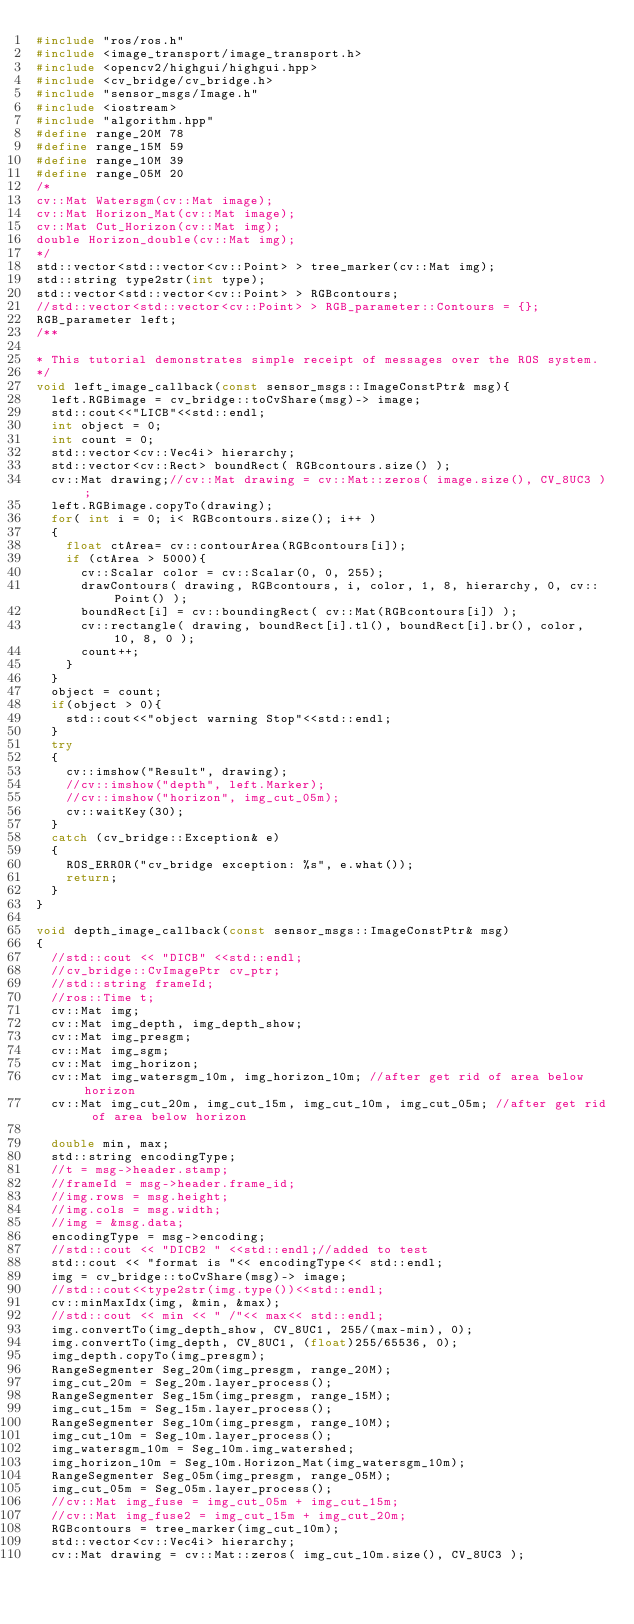<code> <loc_0><loc_0><loc_500><loc_500><_C++_>#include "ros/ros.h"
#include <image_transport/image_transport.h>
#include <opencv2/highgui/highgui.hpp>
#include <cv_bridge/cv_bridge.h>
#include "sensor_msgs/Image.h"
#include <iostream>
#include "algorithm.hpp"
#define range_20M 78
#define range_15M 59
#define range_10M 39
#define range_05M 20
/*
cv::Mat Watersgm(cv::Mat image);
cv::Mat Horizon_Mat(cv::Mat image);
cv::Mat Cut_Horizon(cv::Mat img);
double Horizon_double(cv::Mat img);
*/
std::vector<std::vector<cv::Point> > tree_marker(cv::Mat img);
std::string type2str(int type);
std::vector<std::vector<cv::Point> > RGBcontours;
//std::vector<std::vector<cv::Point> > RGB_parameter::Contours = {};
RGB_parameter left;
/**

* This tutorial demonstrates simple receipt of messages over the ROS system.
*/
void left_image_callback(const sensor_msgs::ImageConstPtr& msg){
	left.RGBimage = cv_bridge::toCvShare(msg)-> image;
	std::cout<<"LICB"<<std::endl;
	int object = 0;
	int count = 0;
	std::vector<cv::Vec4i> hierarchy;
	std::vector<cv::Rect> boundRect( RGBcontours.size() );
	cv::Mat drawing;//cv::Mat drawing = cv::Mat::zeros( image.size(), CV_8UC3 );
	left.RGBimage.copyTo(drawing);
	for( int i = 0; i< RGBcontours.size(); i++ )
	{
		float ctArea= cv::contourArea(RGBcontours[i]);
		if (ctArea > 5000){
			cv::Scalar color = cv::Scalar(0, 0, 255);
			drawContours( drawing, RGBcontours, i, color, 1, 8, hierarchy, 0, cv::Point() );
			boundRect[i] = cv::boundingRect( cv::Mat(RGBcontours[i]) );
			cv::rectangle( drawing, boundRect[i].tl(), boundRect[i].br(), color, 10, 8, 0 );
			count++;
		}
	}
	object = count;
	if(object > 0){
		std::cout<<"object warning Stop"<<std::endl;
	}
	try
	{
		cv::imshow("Result", drawing);
		//cv::imshow("depth", left.Marker);
		//cv::imshow("horizon", img_cut_05m);
		cv::waitKey(30);
	}
	catch (cv_bridge::Exception& e)
	{
		ROS_ERROR("cv_bridge exception: %s", e.what());
		return;
	}
}

void depth_image_callback(const sensor_msgs::ImageConstPtr& msg)
{
	//std::cout << "DICB" <<std::endl;
	//cv_bridge::CvImagePtr cv_ptr;
	//std::string frameId;
	//ros::Time t;
	cv::Mat img;
	cv::Mat img_depth, img_depth_show;
	cv::Mat img_presgm;
	cv::Mat img_sgm;
	cv::Mat img_horizon;
	cv::Mat img_watersgm_10m, img_horizon_10m; //after get rid of area below horizon
	cv::Mat img_cut_20m, img_cut_15m, img_cut_10m, img_cut_05m; //after get rid of area below horizon

	double min, max;
	std::string encodingType;
	//t = msg->header.stamp;
	//frameId = msg->header.frame_id;
	//img.rows = msg.height;
	//img.cols = msg.width;
	//img = &msg.data;
	encodingType = msg->encoding;
	//std::cout << "DICB2 " <<std::endl;//added to test
	std::cout << "format is "<< encodingType<< std::endl;
	img = cv_bridge::toCvShare(msg)-> image;
	//std::cout<<type2str(img.type())<<std::endl;
	cv::minMaxIdx(img, &min, &max);
	//std::cout << min << " /"<< max<< std::endl;
	img.convertTo(img_depth_show, CV_8UC1, 255/(max-min), 0);
	img.convertTo(img_depth, CV_8UC1, (float)255/65536, 0);
	img_depth.copyTo(img_presgm);
	RangeSegmenter Seg_20m(img_presgm, range_20M);
	img_cut_20m = Seg_20m.layer_process();
	RangeSegmenter Seg_15m(img_presgm, range_15M);
	img_cut_15m = Seg_15m.layer_process();
	RangeSegmenter Seg_10m(img_presgm, range_10M);
	img_cut_10m = Seg_10m.layer_process();
	img_watersgm_10m = Seg_10m.img_watershed;
	img_horizon_10m = Seg_10m.Horizon_Mat(img_watersgm_10m);
	RangeSegmenter Seg_05m(img_presgm, range_05M);
	img_cut_05m = Seg_05m.layer_process();
	//cv::Mat img_fuse = img_cut_05m + img_cut_15m;
	//cv::Mat img_fuse2 = img_cut_15m + img_cut_20m;
	RGBcontours = tree_marker(img_cut_10m);
	std::vector<cv::Vec4i> hierarchy;
	cv::Mat drawing = cv::Mat::zeros( img_cut_10m.size(), CV_8UC3 );</code> 